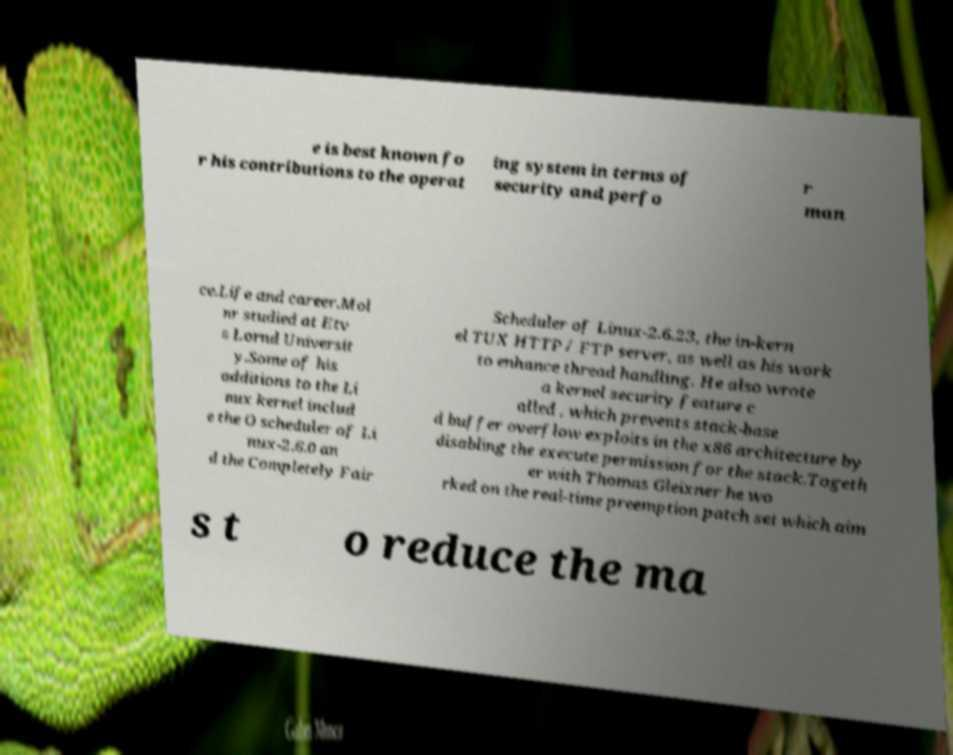Can you read and provide the text displayed in the image?This photo seems to have some interesting text. Can you extract and type it out for me? e is best known fo r his contributions to the operat ing system in terms of security and perfo r man ce.Life and career.Mol nr studied at Etv s Lornd Universit y.Some of his additions to the Li nux kernel includ e the O scheduler of Li nux-2.6.0 an d the Completely Fair Scheduler of Linux-2.6.23, the in-kern el TUX HTTP / FTP server, as well as his work to enhance thread handling. He also wrote a kernel security feature c alled , which prevents stack-base d buffer overflow exploits in the x86 architecture by disabling the execute permission for the stack.Togeth er with Thomas Gleixner he wo rked on the real-time preemption patch set which aim s t o reduce the ma 